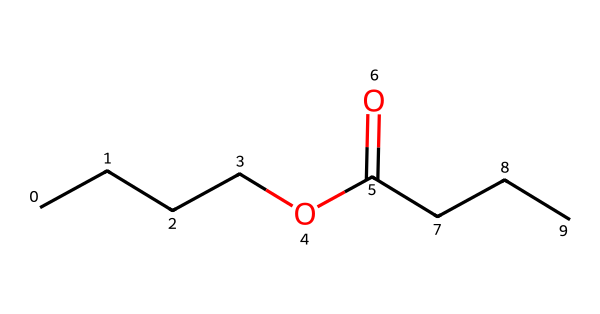What is the molecular formula of butyl butyrate? The molecular formula can be derived by counting the types of atoms in the SMILES representation. The four 'C' in the butyl group, two 'C' in the carbonyl group (from C(=O)), and three 'C' in the butyrate give a total of nine 'C'. Additionally, there are sixteen 'H' from numerous connections (and one 'O' from the carbonyl and one from the ether part). Hence, the complete molecular formula is C9H16O2.
Answer: C9H16O2 How many carbon atoms are in butyl butyrate? By examining the structure represented in the SMILES notation, we see that there are nine 'C' characters, which indicates that there are nine carbon atoms present in the molecule.
Answer: 9 What functional groups are present in butyl butyrate? The molecule contains two functional groups: an ester functional group (indicated by the -COO- part) and an ether group which is part of the molecule's structure. Both of these are critical to the compound's classification as an ester.
Answer: ester and ether Which part of butyl butyrate contributes to its fruity odor? The ester linkage (the R-COOC part of the structure) provides the fruity odor characteristic associated with many esters, including the pineapple-like scent of butyl butyrate. This segment is significant for its sensory properties.
Answer: ester linkage What is the total number of oxygen atoms in butyl butyrate? From the SMILES representation, there are two 'O' characters, indicating that butyl butyrate contains two oxygen atoms. Each oxygen is involved in different functional roles in the molecule.
Answer: 2 How does the structure of butyl butyrate relate to its use in cleaning products? The nonpolar hydrocarbon chains in butyl butyrate aid in solubilizing or breaking down oils and grease, making it effective for cleaning purposes, while its pleasant odor makes it appealing in formulations.
Answer: effective solubilizing agent 